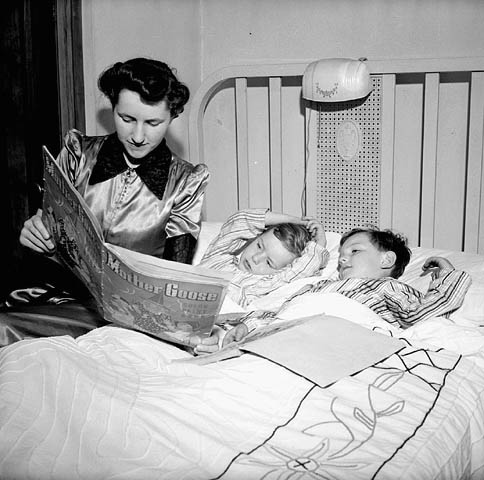Read and extract the text from this image. Mathey Goose 